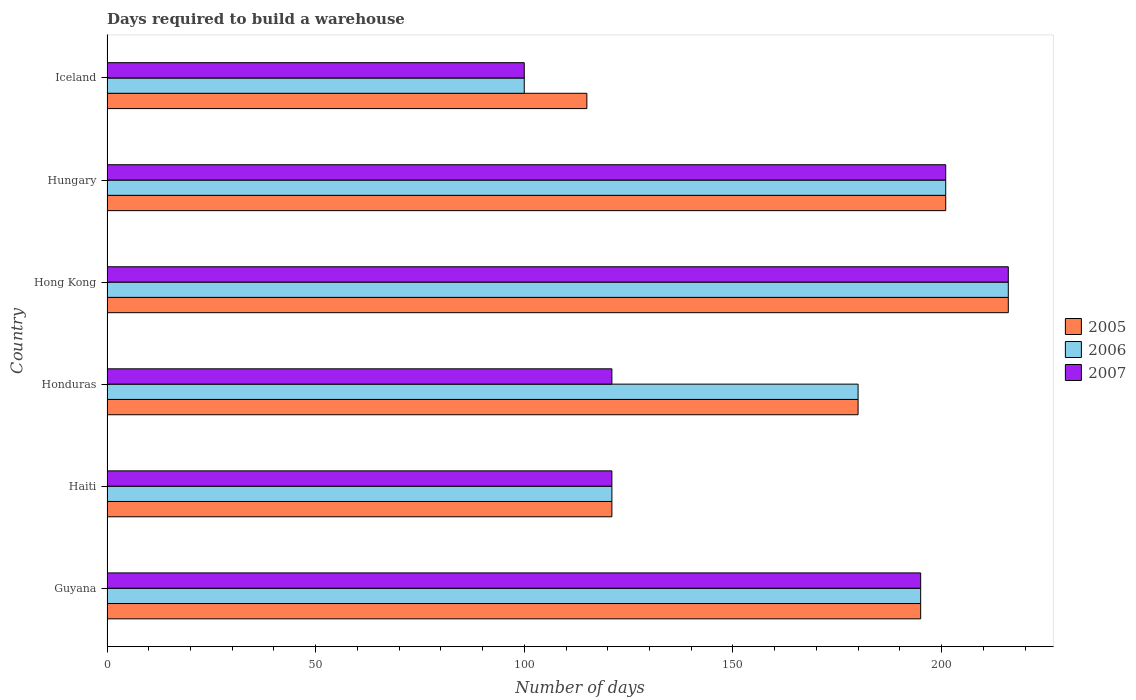How many different coloured bars are there?
Ensure brevity in your answer.  3. Are the number of bars on each tick of the Y-axis equal?
Keep it short and to the point. Yes. What is the label of the 2nd group of bars from the top?
Provide a short and direct response. Hungary. What is the days required to build a warehouse in in 2005 in Hong Kong?
Your answer should be compact. 216. Across all countries, what is the maximum days required to build a warehouse in in 2006?
Provide a short and direct response. 216. Across all countries, what is the minimum days required to build a warehouse in in 2005?
Provide a short and direct response. 115. In which country was the days required to build a warehouse in in 2005 maximum?
Your answer should be compact. Hong Kong. What is the total days required to build a warehouse in in 2006 in the graph?
Offer a terse response. 1013. What is the difference between the days required to build a warehouse in in 2007 in Haiti and that in Hungary?
Provide a short and direct response. -80. What is the difference between the days required to build a warehouse in in 2005 in Honduras and the days required to build a warehouse in in 2006 in Iceland?
Provide a short and direct response. 80. What is the average days required to build a warehouse in in 2007 per country?
Keep it short and to the point. 159. In how many countries, is the days required to build a warehouse in in 2007 greater than 100 days?
Offer a very short reply. 5. What is the ratio of the days required to build a warehouse in in 2005 in Haiti to that in Hungary?
Provide a short and direct response. 0.6. Is the difference between the days required to build a warehouse in in 2005 in Honduras and Hong Kong greater than the difference between the days required to build a warehouse in in 2007 in Honduras and Hong Kong?
Give a very brief answer. Yes. What is the difference between the highest and the lowest days required to build a warehouse in in 2006?
Offer a terse response. 116. In how many countries, is the days required to build a warehouse in in 2007 greater than the average days required to build a warehouse in in 2007 taken over all countries?
Your answer should be compact. 3. Is the sum of the days required to build a warehouse in in 2006 in Hong Kong and Hungary greater than the maximum days required to build a warehouse in in 2005 across all countries?
Your response must be concise. Yes. Is it the case that in every country, the sum of the days required to build a warehouse in in 2006 and days required to build a warehouse in in 2007 is greater than the days required to build a warehouse in in 2005?
Make the answer very short. Yes. How many bars are there?
Your answer should be compact. 18. How many countries are there in the graph?
Make the answer very short. 6. What is the difference between two consecutive major ticks on the X-axis?
Offer a terse response. 50. How many legend labels are there?
Provide a succinct answer. 3. What is the title of the graph?
Your answer should be compact. Days required to build a warehouse. Does "2005" appear as one of the legend labels in the graph?
Keep it short and to the point. Yes. What is the label or title of the X-axis?
Keep it short and to the point. Number of days. What is the Number of days of 2005 in Guyana?
Keep it short and to the point. 195. What is the Number of days in 2006 in Guyana?
Your answer should be compact. 195. What is the Number of days in 2007 in Guyana?
Offer a terse response. 195. What is the Number of days of 2005 in Haiti?
Offer a terse response. 121. What is the Number of days of 2006 in Haiti?
Provide a succinct answer. 121. What is the Number of days of 2007 in Haiti?
Give a very brief answer. 121. What is the Number of days of 2005 in Honduras?
Make the answer very short. 180. What is the Number of days in 2006 in Honduras?
Your answer should be compact. 180. What is the Number of days in 2007 in Honduras?
Provide a succinct answer. 121. What is the Number of days in 2005 in Hong Kong?
Your response must be concise. 216. What is the Number of days in 2006 in Hong Kong?
Provide a succinct answer. 216. What is the Number of days of 2007 in Hong Kong?
Make the answer very short. 216. What is the Number of days in 2005 in Hungary?
Your response must be concise. 201. What is the Number of days of 2006 in Hungary?
Your answer should be very brief. 201. What is the Number of days of 2007 in Hungary?
Ensure brevity in your answer.  201. What is the Number of days of 2005 in Iceland?
Keep it short and to the point. 115. What is the Number of days of 2006 in Iceland?
Your answer should be compact. 100. Across all countries, what is the maximum Number of days of 2005?
Provide a short and direct response. 216. Across all countries, what is the maximum Number of days in 2006?
Provide a short and direct response. 216. Across all countries, what is the maximum Number of days of 2007?
Your response must be concise. 216. Across all countries, what is the minimum Number of days of 2005?
Your answer should be compact. 115. What is the total Number of days of 2005 in the graph?
Provide a succinct answer. 1028. What is the total Number of days of 2006 in the graph?
Offer a terse response. 1013. What is the total Number of days of 2007 in the graph?
Provide a succinct answer. 954. What is the difference between the Number of days in 2005 in Guyana and that in Haiti?
Provide a short and direct response. 74. What is the difference between the Number of days in 2006 in Guyana and that in Haiti?
Offer a terse response. 74. What is the difference between the Number of days in 2005 in Guyana and that in Honduras?
Give a very brief answer. 15. What is the difference between the Number of days in 2006 in Guyana and that in Honduras?
Keep it short and to the point. 15. What is the difference between the Number of days of 2007 in Guyana and that in Honduras?
Your response must be concise. 74. What is the difference between the Number of days of 2006 in Guyana and that in Hong Kong?
Keep it short and to the point. -21. What is the difference between the Number of days of 2007 in Guyana and that in Hong Kong?
Provide a short and direct response. -21. What is the difference between the Number of days in 2006 in Guyana and that in Hungary?
Your answer should be compact. -6. What is the difference between the Number of days in 2007 in Guyana and that in Iceland?
Keep it short and to the point. 95. What is the difference between the Number of days of 2005 in Haiti and that in Honduras?
Give a very brief answer. -59. What is the difference between the Number of days of 2006 in Haiti and that in Honduras?
Give a very brief answer. -59. What is the difference between the Number of days in 2005 in Haiti and that in Hong Kong?
Offer a terse response. -95. What is the difference between the Number of days in 2006 in Haiti and that in Hong Kong?
Provide a succinct answer. -95. What is the difference between the Number of days in 2007 in Haiti and that in Hong Kong?
Offer a terse response. -95. What is the difference between the Number of days in 2005 in Haiti and that in Hungary?
Your response must be concise. -80. What is the difference between the Number of days of 2006 in Haiti and that in Hungary?
Keep it short and to the point. -80. What is the difference between the Number of days in 2007 in Haiti and that in Hungary?
Give a very brief answer. -80. What is the difference between the Number of days in 2006 in Haiti and that in Iceland?
Provide a succinct answer. 21. What is the difference between the Number of days in 2007 in Haiti and that in Iceland?
Provide a succinct answer. 21. What is the difference between the Number of days in 2005 in Honduras and that in Hong Kong?
Provide a succinct answer. -36. What is the difference between the Number of days in 2006 in Honduras and that in Hong Kong?
Provide a short and direct response. -36. What is the difference between the Number of days of 2007 in Honduras and that in Hong Kong?
Make the answer very short. -95. What is the difference between the Number of days in 2007 in Honduras and that in Hungary?
Give a very brief answer. -80. What is the difference between the Number of days of 2005 in Honduras and that in Iceland?
Give a very brief answer. 65. What is the difference between the Number of days in 2006 in Honduras and that in Iceland?
Your answer should be very brief. 80. What is the difference between the Number of days in 2007 in Honduras and that in Iceland?
Provide a short and direct response. 21. What is the difference between the Number of days of 2007 in Hong Kong and that in Hungary?
Your response must be concise. 15. What is the difference between the Number of days of 2005 in Hong Kong and that in Iceland?
Offer a very short reply. 101. What is the difference between the Number of days of 2006 in Hong Kong and that in Iceland?
Your answer should be compact. 116. What is the difference between the Number of days in 2007 in Hong Kong and that in Iceland?
Offer a terse response. 116. What is the difference between the Number of days in 2005 in Hungary and that in Iceland?
Make the answer very short. 86. What is the difference between the Number of days of 2006 in Hungary and that in Iceland?
Give a very brief answer. 101. What is the difference between the Number of days of 2007 in Hungary and that in Iceland?
Keep it short and to the point. 101. What is the difference between the Number of days in 2005 in Guyana and the Number of days in 2006 in Haiti?
Offer a very short reply. 74. What is the difference between the Number of days of 2005 in Guyana and the Number of days of 2007 in Haiti?
Your answer should be very brief. 74. What is the difference between the Number of days of 2005 in Guyana and the Number of days of 2007 in Honduras?
Make the answer very short. 74. What is the difference between the Number of days in 2006 in Guyana and the Number of days in 2007 in Honduras?
Your response must be concise. 74. What is the difference between the Number of days in 2005 in Guyana and the Number of days in 2007 in Hong Kong?
Make the answer very short. -21. What is the difference between the Number of days in 2005 in Guyana and the Number of days in 2007 in Hungary?
Ensure brevity in your answer.  -6. What is the difference between the Number of days in 2006 in Guyana and the Number of days in 2007 in Iceland?
Provide a short and direct response. 95. What is the difference between the Number of days in 2005 in Haiti and the Number of days in 2006 in Honduras?
Give a very brief answer. -59. What is the difference between the Number of days in 2005 in Haiti and the Number of days in 2007 in Honduras?
Make the answer very short. 0. What is the difference between the Number of days in 2006 in Haiti and the Number of days in 2007 in Honduras?
Your answer should be compact. 0. What is the difference between the Number of days of 2005 in Haiti and the Number of days of 2006 in Hong Kong?
Give a very brief answer. -95. What is the difference between the Number of days in 2005 in Haiti and the Number of days in 2007 in Hong Kong?
Offer a terse response. -95. What is the difference between the Number of days in 2006 in Haiti and the Number of days in 2007 in Hong Kong?
Make the answer very short. -95. What is the difference between the Number of days of 2005 in Haiti and the Number of days of 2006 in Hungary?
Your answer should be very brief. -80. What is the difference between the Number of days of 2005 in Haiti and the Number of days of 2007 in Hungary?
Your answer should be very brief. -80. What is the difference between the Number of days of 2006 in Haiti and the Number of days of 2007 in Hungary?
Provide a succinct answer. -80. What is the difference between the Number of days in 2005 in Haiti and the Number of days in 2006 in Iceland?
Make the answer very short. 21. What is the difference between the Number of days in 2005 in Honduras and the Number of days in 2006 in Hong Kong?
Offer a terse response. -36. What is the difference between the Number of days of 2005 in Honduras and the Number of days of 2007 in Hong Kong?
Offer a very short reply. -36. What is the difference between the Number of days in 2006 in Honduras and the Number of days in 2007 in Hong Kong?
Your answer should be compact. -36. What is the difference between the Number of days of 2005 in Honduras and the Number of days of 2007 in Hungary?
Keep it short and to the point. -21. What is the difference between the Number of days in 2006 in Honduras and the Number of days in 2007 in Iceland?
Keep it short and to the point. 80. What is the difference between the Number of days of 2005 in Hong Kong and the Number of days of 2006 in Hungary?
Give a very brief answer. 15. What is the difference between the Number of days of 2005 in Hong Kong and the Number of days of 2006 in Iceland?
Your response must be concise. 116. What is the difference between the Number of days in 2005 in Hong Kong and the Number of days in 2007 in Iceland?
Keep it short and to the point. 116. What is the difference between the Number of days of 2006 in Hong Kong and the Number of days of 2007 in Iceland?
Your answer should be very brief. 116. What is the difference between the Number of days in 2005 in Hungary and the Number of days in 2006 in Iceland?
Keep it short and to the point. 101. What is the difference between the Number of days in 2005 in Hungary and the Number of days in 2007 in Iceland?
Your answer should be compact. 101. What is the difference between the Number of days in 2006 in Hungary and the Number of days in 2007 in Iceland?
Ensure brevity in your answer.  101. What is the average Number of days in 2005 per country?
Your answer should be compact. 171.33. What is the average Number of days of 2006 per country?
Give a very brief answer. 168.83. What is the average Number of days of 2007 per country?
Your answer should be very brief. 159. What is the difference between the Number of days in 2005 and Number of days in 2006 in Haiti?
Keep it short and to the point. 0. What is the difference between the Number of days of 2005 and Number of days of 2006 in Honduras?
Make the answer very short. 0. What is the difference between the Number of days in 2005 and Number of days in 2007 in Honduras?
Your response must be concise. 59. What is the difference between the Number of days in 2005 and Number of days in 2006 in Hong Kong?
Provide a succinct answer. 0. What is the difference between the Number of days in 2005 and Number of days in 2007 in Hong Kong?
Give a very brief answer. 0. What is the difference between the Number of days of 2006 and Number of days of 2007 in Hong Kong?
Keep it short and to the point. 0. What is the difference between the Number of days in 2005 and Number of days in 2006 in Hungary?
Provide a short and direct response. 0. What is the difference between the Number of days in 2006 and Number of days in 2007 in Iceland?
Make the answer very short. 0. What is the ratio of the Number of days of 2005 in Guyana to that in Haiti?
Your answer should be very brief. 1.61. What is the ratio of the Number of days of 2006 in Guyana to that in Haiti?
Your response must be concise. 1.61. What is the ratio of the Number of days in 2007 in Guyana to that in Haiti?
Your answer should be compact. 1.61. What is the ratio of the Number of days of 2005 in Guyana to that in Honduras?
Ensure brevity in your answer.  1.08. What is the ratio of the Number of days of 2007 in Guyana to that in Honduras?
Keep it short and to the point. 1.61. What is the ratio of the Number of days of 2005 in Guyana to that in Hong Kong?
Offer a terse response. 0.9. What is the ratio of the Number of days of 2006 in Guyana to that in Hong Kong?
Your response must be concise. 0.9. What is the ratio of the Number of days of 2007 in Guyana to that in Hong Kong?
Offer a terse response. 0.9. What is the ratio of the Number of days of 2005 in Guyana to that in Hungary?
Your answer should be compact. 0.97. What is the ratio of the Number of days of 2006 in Guyana to that in Hungary?
Offer a very short reply. 0.97. What is the ratio of the Number of days in 2007 in Guyana to that in Hungary?
Keep it short and to the point. 0.97. What is the ratio of the Number of days of 2005 in Guyana to that in Iceland?
Offer a terse response. 1.7. What is the ratio of the Number of days in 2006 in Guyana to that in Iceland?
Your answer should be compact. 1.95. What is the ratio of the Number of days in 2007 in Guyana to that in Iceland?
Ensure brevity in your answer.  1.95. What is the ratio of the Number of days in 2005 in Haiti to that in Honduras?
Provide a short and direct response. 0.67. What is the ratio of the Number of days in 2006 in Haiti to that in Honduras?
Make the answer very short. 0.67. What is the ratio of the Number of days in 2005 in Haiti to that in Hong Kong?
Provide a short and direct response. 0.56. What is the ratio of the Number of days of 2006 in Haiti to that in Hong Kong?
Give a very brief answer. 0.56. What is the ratio of the Number of days of 2007 in Haiti to that in Hong Kong?
Make the answer very short. 0.56. What is the ratio of the Number of days of 2005 in Haiti to that in Hungary?
Provide a succinct answer. 0.6. What is the ratio of the Number of days in 2006 in Haiti to that in Hungary?
Provide a succinct answer. 0.6. What is the ratio of the Number of days in 2007 in Haiti to that in Hungary?
Your answer should be compact. 0.6. What is the ratio of the Number of days in 2005 in Haiti to that in Iceland?
Your response must be concise. 1.05. What is the ratio of the Number of days of 2006 in Haiti to that in Iceland?
Provide a short and direct response. 1.21. What is the ratio of the Number of days of 2007 in Haiti to that in Iceland?
Keep it short and to the point. 1.21. What is the ratio of the Number of days of 2005 in Honduras to that in Hong Kong?
Make the answer very short. 0.83. What is the ratio of the Number of days of 2006 in Honduras to that in Hong Kong?
Ensure brevity in your answer.  0.83. What is the ratio of the Number of days in 2007 in Honduras to that in Hong Kong?
Make the answer very short. 0.56. What is the ratio of the Number of days of 2005 in Honduras to that in Hungary?
Ensure brevity in your answer.  0.9. What is the ratio of the Number of days in 2006 in Honduras to that in Hungary?
Offer a very short reply. 0.9. What is the ratio of the Number of days in 2007 in Honduras to that in Hungary?
Ensure brevity in your answer.  0.6. What is the ratio of the Number of days of 2005 in Honduras to that in Iceland?
Offer a very short reply. 1.57. What is the ratio of the Number of days in 2006 in Honduras to that in Iceland?
Give a very brief answer. 1.8. What is the ratio of the Number of days in 2007 in Honduras to that in Iceland?
Give a very brief answer. 1.21. What is the ratio of the Number of days in 2005 in Hong Kong to that in Hungary?
Your answer should be very brief. 1.07. What is the ratio of the Number of days of 2006 in Hong Kong to that in Hungary?
Make the answer very short. 1.07. What is the ratio of the Number of days of 2007 in Hong Kong to that in Hungary?
Your answer should be compact. 1.07. What is the ratio of the Number of days in 2005 in Hong Kong to that in Iceland?
Your answer should be compact. 1.88. What is the ratio of the Number of days in 2006 in Hong Kong to that in Iceland?
Provide a short and direct response. 2.16. What is the ratio of the Number of days of 2007 in Hong Kong to that in Iceland?
Offer a terse response. 2.16. What is the ratio of the Number of days in 2005 in Hungary to that in Iceland?
Make the answer very short. 1.75. What is the ratio of the Number of days of 2006 in Hungary to that in Iceland?
Your answer should be compact. 2.01. What is the ratio of the Number of days of 2007 in Hungary to that in Iceland?
Your response must be concise. 2.01. What is the difference between the highest and the second highest Number of days of 2005?
Keep it short and to the point. 15. What is the difference between the highest and the lowest Number of days in 2005?
Keep it short and to the point. 101. What is the difference between the highest and the lowest Number of days of 2006?
Provide a short and direct response. 116. What is the difference between the highest and the lowest Number of days of 2007?
Give a very brief answer. 116. 